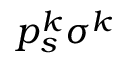Convert formula to latex. <formula><loc_0><loc_0><loc_500><loc_500>p _ { s } ^ { k } \sigma ^ { k }</formula> 